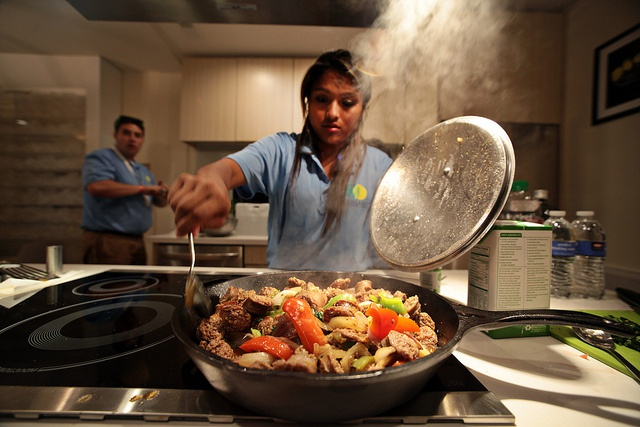Describe the objects in this image and their specific colors. I can see people in black, gray, darkgray, and maroon tones, people in black, maroon, and gray tones, bottle in black and gray tones, bottle in black and gray tones, and spoon in black, maroon, and ivory tones in this image. 